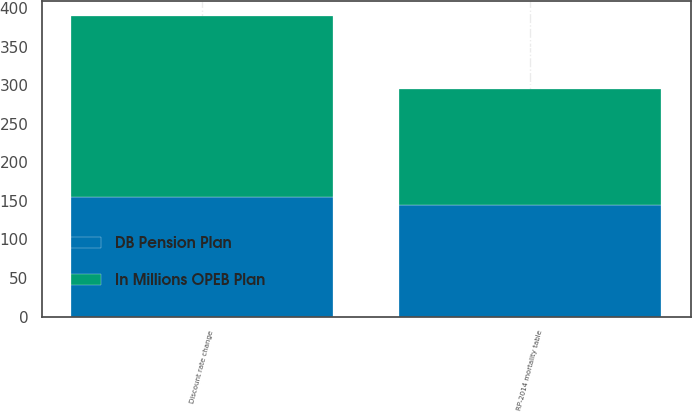Convert chart to OTSL. <chart><loc_0><loc_0><loc_500><loc_500><stacked_bar_chart><ecel><fcel>Discount rate change<fcel>RP-2014 mortality table<nl><fcel>In Millions OPEB Plan<fcel>235<fcel>150<nl><fcel>DB Pension Plan<fcel>155<fcel>145<nl></chart> 